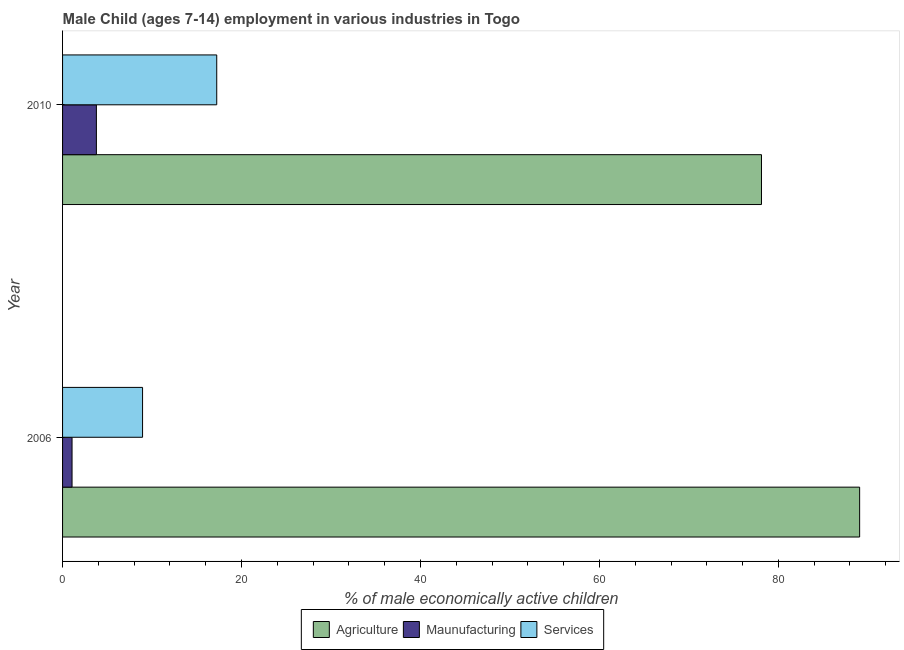Are the number of bars per tick equal to the number of legend labels?
Provide a succinct answer. Yes. Are the number of bars on each tick of the Y-axis equal?
Provide a succinct answer. Yes. How many bars are there on the 2nd tick from the top?
Ensure brevity in your answer.  3. In how many cases, is the number of bars for a given year not equal to the number of legend labels?
Ensure brevity in your answer.  0. What is the percentage of economically active children in agriculture in 2010?
Keep it short and to the point. 78.11. Across all years, what is the maximum percentage of economically active children in services?
Ensure brevity in your answer.  17.23. Across all years, what is the minimum percentage of economically active children in agriculture?
Ensure brevity in your answer.  78.11. In which year was the percentage of economically active children in manufacturing maximum?
Your answer should be compact. 2010. What is the total percentage of economically active children in manufacturing in the graph?
Ensure brevity in your answer.  4.84. What is the difference between the percentage of economically active children in services in 2006 and that in 2010?
Your answer should be very brief. -8.29. What is the difference between the percentage of economically active children in agriculture in 2010 and the percentage of economically active children in manufacturing in 2006?
Provide a short and direct response. 77.05. What is the average percentage of economically active children in agriculture per year?
Offer a terse response. 83.59. In the year 2010, what is the difference between the percentage of economically active children in manufacturing and percentage of economically active children in agriculture?
Offer a very short reply. -74.33. What is the ratio of the percentage of economically active children in agriculture in 2006 to that in 2010?
Provide a succinct answer. 1.14. In how many years, is the percentage of economically active children in manufacturing greater than the average percentage of economically active children in manufacturing taken over all years?
Provide a short and direct response. 1. What does the 3rd bar from the top in 2006 represents?
Offer a terse response. Agriculture. What does the 2nd bar from the bottom in 2010 represents?
Your answer should be compact. Maunufacturing. How many bars are there?
Ensure brevity in your answer.  6. Are all the bars in the graph horizontal?
Provide a short and direct response. Yes. How many years are there in the graph?
Your response must be concise. 2. Are the values on the major ticks of X-axis written in scientific E-notation?
Your answer should be very brief. No. Where does the legend appear in the graph?
Provide a succinct answer. Bottom center. What is the title of the graph?
Offer a very short reply. Male Child (ages 7-14) employment in various industries in Togo. Does "Hydroelectric sources" appear as one of the legend labels in the graph?
Your response must be concise. No. What is the label or title of the X-axis?
Give a very brief answer. % of male economically active children. What is the label or title of the Y-axis?
Offer a terse response. Year. What is the % of male economically active children in Agriculture in 2006?
Your answer should be very brief. 89.08. What is the % of male economically active children of Maunufacturing in 2006?
Your answer should be very brief. 1.06. What is the % of male economically active children in Services in 2006?
Your answer should be compact. 8.94. What is the % of male economically active children of Agriculture in 2010?
Your response must be concise. 78.11. What is the % of male economically active children of Maunufacturing in 2010?
Offer a very short reply. 3.78. What is the % of male economically active children of Services in 2010?
Provide a succinct answer. 17.23. Across all years, what is the maximum % of male economically active children in Agriculture?
Provide a short and direct response. 89.08. Across all years, what is the maximum % of male economically active children of Maunufacturing?
Offer a very short reply. 3.78. Across all years, what is the maximum % of male economically active children in Services?
Ensure brevity in your answer.  17.23. Across all years, what is the minimum % of male economically active children in Agriculture?
Provide a short and direct response. 78.11. Across all years, what is the minimum % of male economically active children in Maunufacturing?
Your answer should be very brief. 1.06. Across all years, what is the minimum % of male economically active children in Services?
Keep it short and to the point. 8.94. What is the total % of male economically active children of Agriculture in the graph?
Offer a very short reply. 167.19. What is the total % of male economically active children of Maunufacturing in the graph?
Your answer should be compact. 4.84. What is the total % of male economically active children of Services in the graph?
Your answer should be very brief. 26.17. What is the difference between the % of male economically active children in Agriculture in 2006 and that in 2010?
Provide a short and direct response. 10.97. What is the difference between the % of male economically active children of Maunufacturing in 2006 and that in 2010?
Ensure brevity in your answer.  -2.72. What is the difference between the % of male economically active children of Services in 2006 and that in 2010?
Offer a very short reply. -8.29. What is the difference between the % of male economically active children in Agriculture in 2006 and the % of male economically active children in Maunufacturing in 2010?
Give a very brief answer. 85.3. What is the difference between the % of male economically active children in Agriculture in 2006 and the % of male economically active children in Services in 2010?
Keep it short and to the point. 71.85. What is the difference between the % of male economically active children of Maunufacturing in 2006 and the % of male economically active children of Services in 2010?
Provide a succinct answer. -16.17. What is the average % of male economically active children in Agriculture per year?
Make the answer very short. 83.59. What is the average % of male economically active children of Maunufacturing per year?
Keep it short and to the point. 2.42. What is the average % of male economically active children of Services per year?
Your answer should be very brief. 13.09. In the year 2006, what is the difference between the % of male economically active children in Agriculture and % of male economically active children in Maunufacturing?
Your answer should be very brief. 88.02. In the year 2006, what is the difference between the % of male economically active children in Agriculture and % of male economically active children in Services?
Make the answer very short. 80.14. In the year 2006, what is the difference between the % of male economically active children in Maunufacturing and % of male economically active children in Services?
Keep it short and to the point. -7.88. In the year 2010, what is the difference between the % of male economically active children of Agriculture and % of male economically active children of Maunufacturing?
Make the answer very short. 74.33. In the year 2010, what is the difference between the % of male economically active children of Agriculture and % of male economically active children of Services?
Keep it short and to the point. 60.88. In the year 2010, what is the difference between the % of male economically active children in Maunufacturing and % of male economically active children in Services?
Provide a succinct answer. -13.45. What is the ratio of the % of male economically active children of Agriculture in 2006 to that in 2010?
Ensure brevity in your answer.  1.14. What is the ratio of the % of male economically active children in Maunufacturing in 2006 to that in 2010?
Offer a very short reply. 0.28. What is the ratio of the % of male economically active children of Services in 2006 to that in 2010?
Keep it short and to the point. 0.52. What is the difference between the highest and the second highest % of male economically active children in Agriculture?
Ensure brevity in your answer.  10.97. What is the difference between the highest and the second highest % of male economically active children in Maunufacturing?
Your response must be concise. 2.72. What is the difference between the highest and the second highest % of male economically active children in Services?
Offer a terse response. 8.29. What is the difference between the highest and the lowest % of male economically active children in Agriculture?
Offer a very short reply. 10.97. What is the difference between the highest and the lowest % of male economically active children in Maunufacturing?
Your answer should be very brief. 2.72. What is the difference between the highest and the lowest % of male economically active children of Services?
Offer a very short reply. 8.29. 